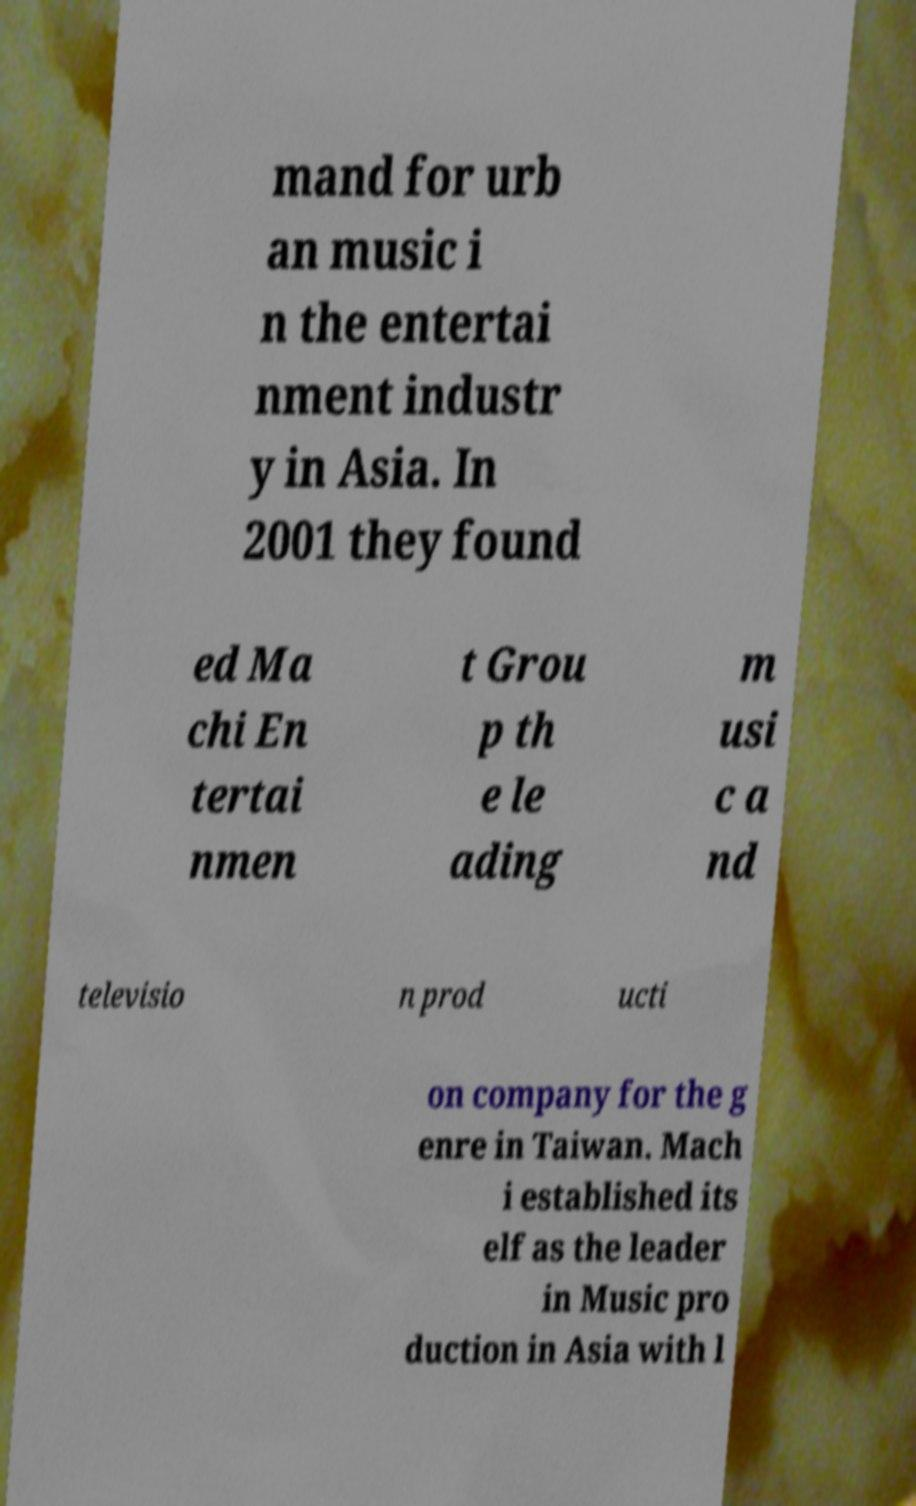Can you accurately transcribe the text from the provided image for me? mand for urb an music i n the entertai nment industr y in Asia. In 2001 they found ed Ma chi En tertai nmen t Grou p th e le ading m usi c a nd televisio n prod ucti on company for the g enre in Taiwan. Mach i established its elf as the leader in Music pro duction in Asia with l 